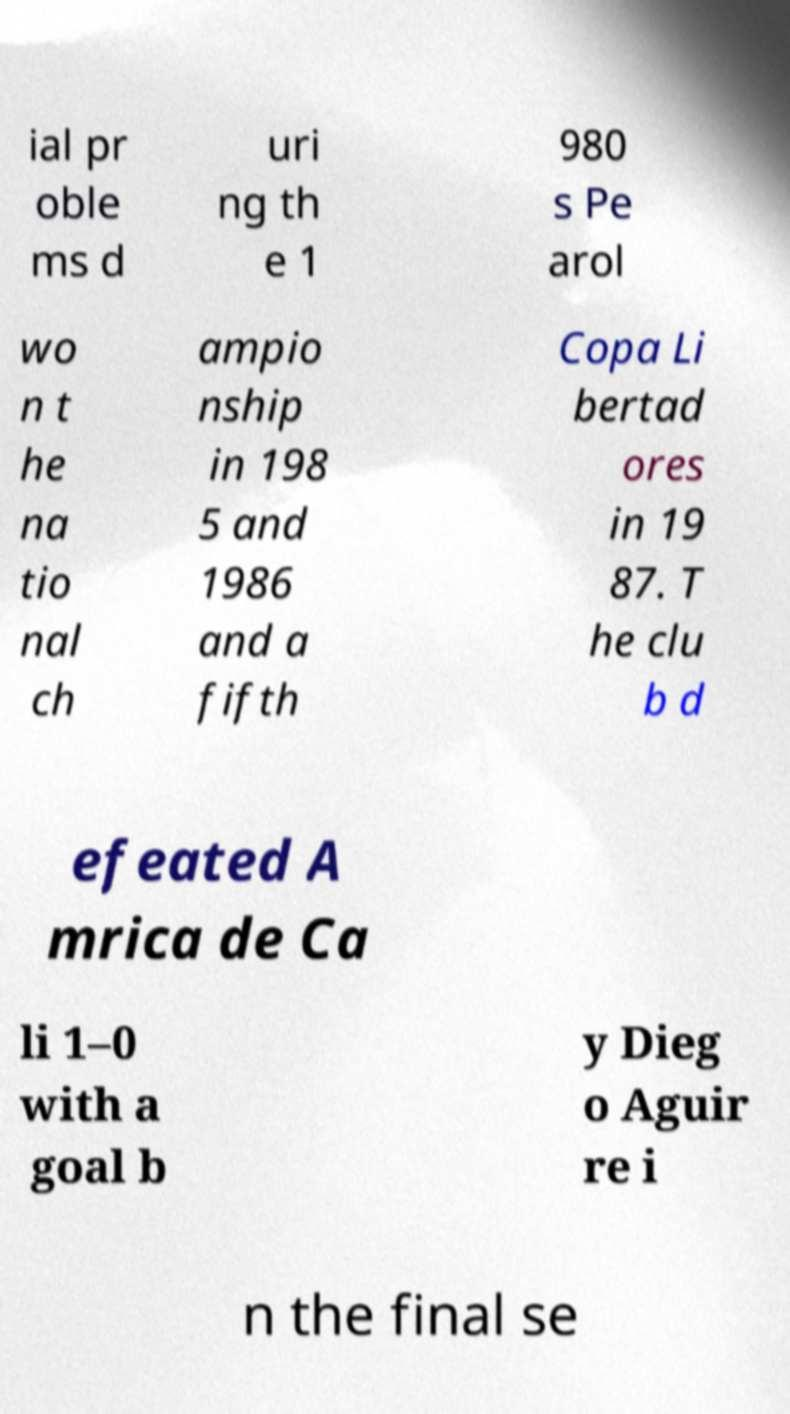There's text embedded in this image that I need extracted. Can you transcribe it verbatim? ial pr oble ms d uri ng th e 1 980 s Pe arol wo n t he na tio nal ch ampio nship in 198 5 and 1986 and a fifth Copa Li bertad ores in 19 87. T he clu b d efeated A mrica de Ca li 1–0 with a goal b y Dieg o Aguir re i n the final se 